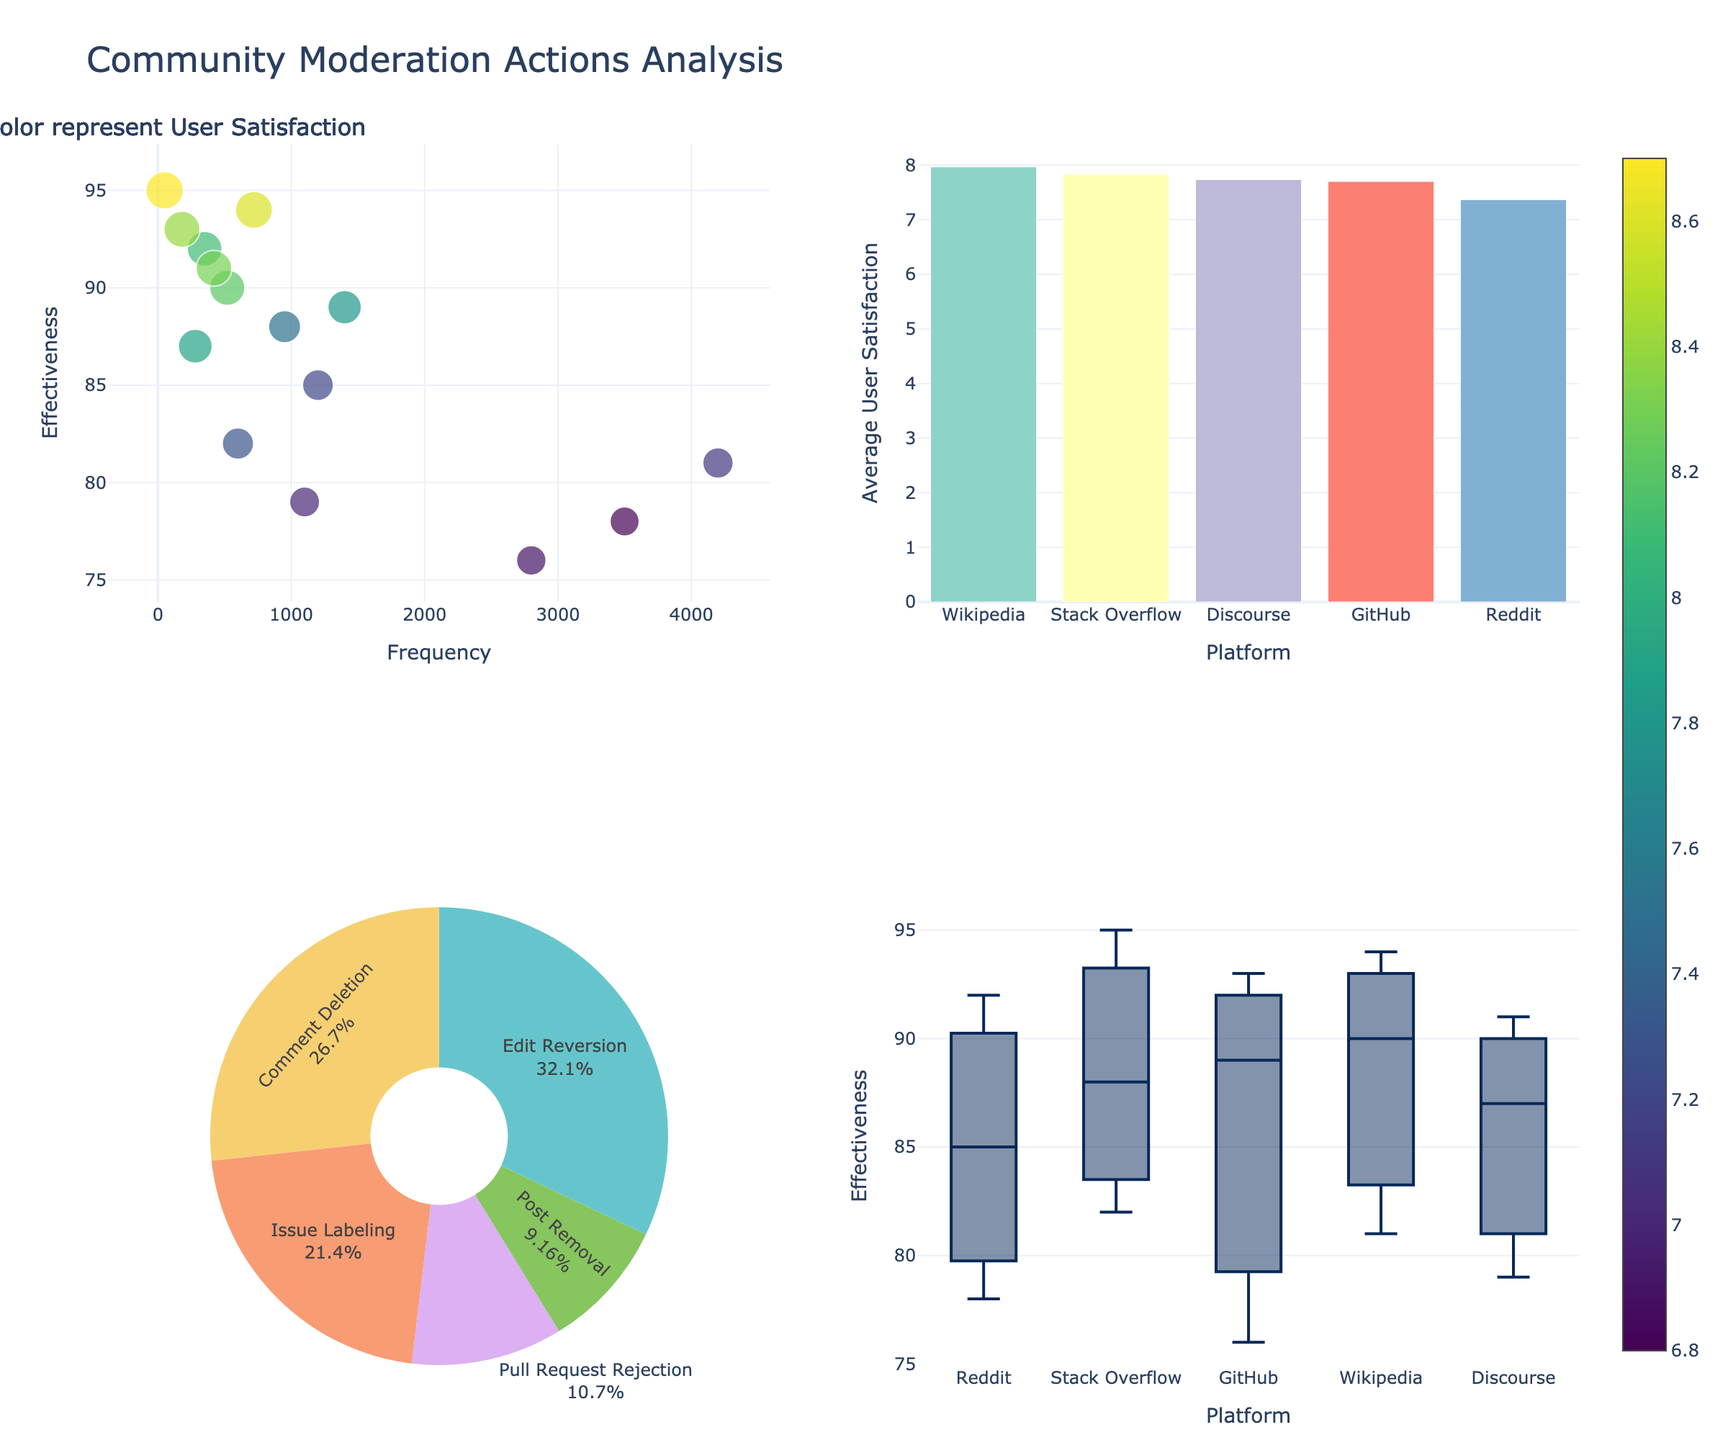Which country has the highest percentage of Native speakers in the 18-25 age group? Refer to the United States, China, Germany, Brazil, and Japan subplots for the 18-25 age group and compare the heights of the 'Native' bars. The United States has the highest percentage at 25%.
Answer: The United States What is the total percentage of Advanced speakers across all age groups in Germany? Sum the percentages of Advanced speakers for all age groups in Germany: 45% (18-25) + 40% (26-40) + 35% (41-60) + 30% (61+). The total is 150%.
Answer: 150% Which age group in Brazil has the lowest percentage of Intermediate speakers? Look at the Brazil subplot and compare the heights of the 'Intermediate' bars for each age group. The 61+ age group has the lowest percentage at 40%.
Answer: 61+ age group In China, which proficiency level shows the highest increase as age increases from 18-25 to 61+? Compare the 'Beginner', 'Intermediate', 'Advanced', and 'Native' percentages from 18-25 to 61+. The highest increase is seen in 'Beginner': from 30% to 45%.
Answer: Beginner How does the percentage of Native speakers in Japan change with age? In the Japan subplot, observe the 'Native' bars from 18-25 to 61+. All age groups have 5% for Native speakers; hence, there is no change.
Answer: No change Which country has the most balanced distribution of language proficiency levels across all age groups? A balanced distribution would mean similar percentages for all proficiency levels within each age group. Observe each country’s subplot. Germany and Brazil show relatively balanced distributions compared to others.
Answer: Germany and Brazil How many countries have more than 40% Beginner speakers in the 61+ age group? Check the 61+ age group bar for 'Beginner' in each country’s subplot. China, Brazil, and Japan each have more than 40%. That’s three countries.
Answer: Three countries Which proficiency level in the United States shows a consistent increase or decrease across all age groups? Observe each proficiency bar (Beginner, Intermediate, Advanced, Native) in the United States subplot across all age groups. 'Beginner' shows a consistent increase.
Answer: Beginner What is the difference in the percentage of Advanced speakers between the 18-25 and 61+ age groups in Japan? Subtract the percentage of Advanced speakers in the 61+ age group (20%) from the 18-25 age group (30%). The difference is 10%.
Answer: 10% Which age group in China has the highest percentage of Advanced speakers? In the China subplot compare the heights of the 'Advanced' bars for each age group. The 18-25 and 26-40 age groups both have 25%, which is the highest.
Answer: 18-25 and 26-40 age groups 